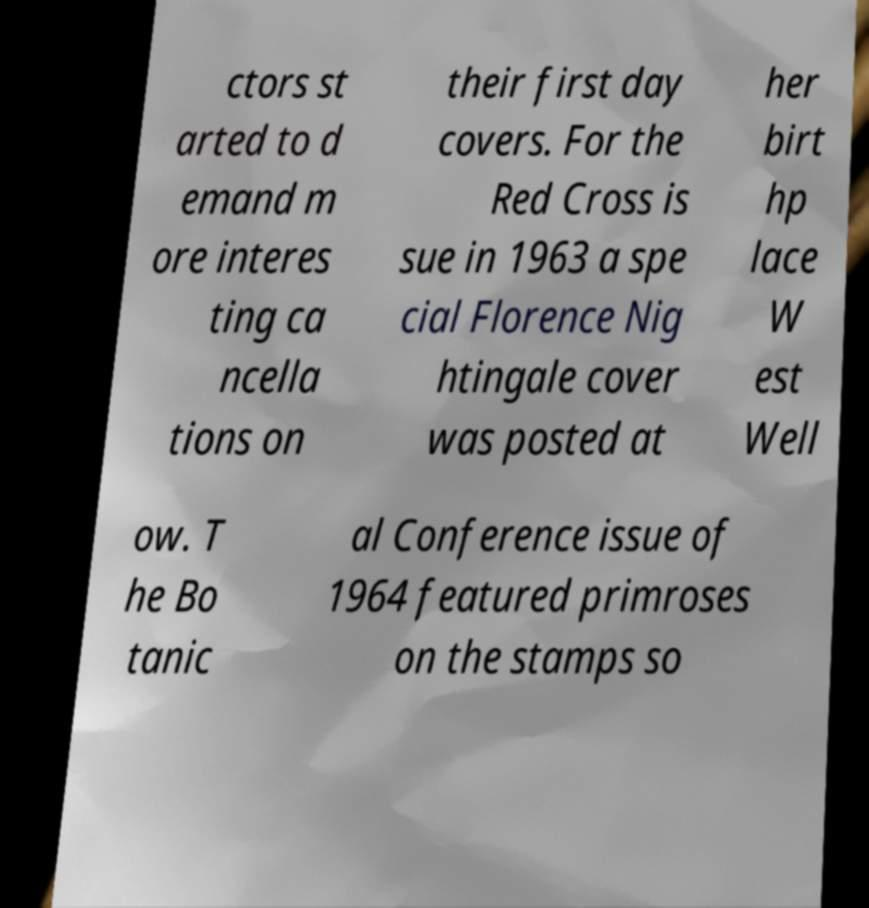There's text embedded in this image that I need extracted. Can you transcribe it verbatim? ctors st arted to d emand m ore interes ting ca ncella tions on their first day covers. For the Red Cross is sue in 1963 a spe cial Florence Nig htingale cover was posted at her birt hp lace W est Well ow. T he Bo tanic al Conference issue of 1964 featured primroses on the stamps so 